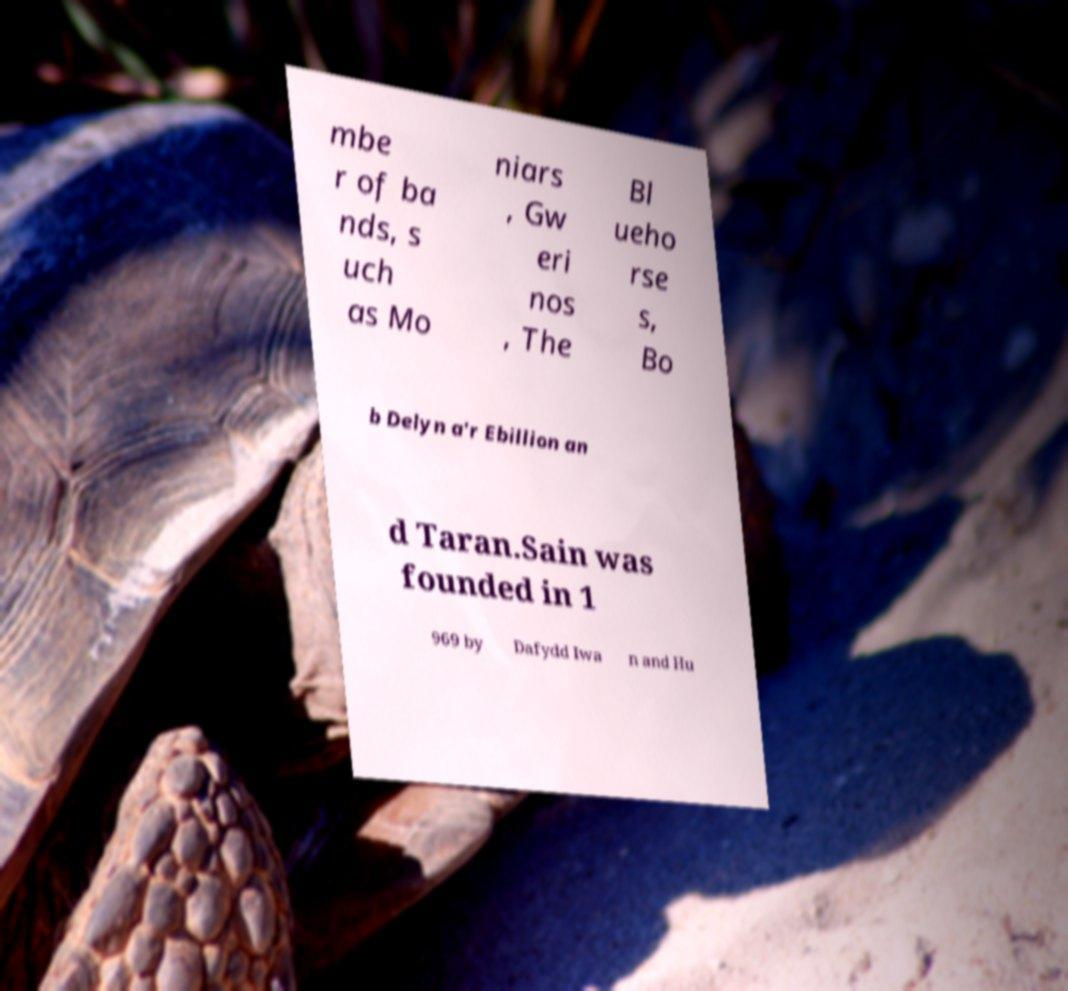Can you accurately transcribe the text from the provided image for me? mbe r of ba nds, s uch as Mo niars , Gw eri nos , The Bl ueho rse s, Bo b Delyn a'r Ebillion an d Taran.Sain was founded in 1 969 by Dafydd Iwa n and Hu 